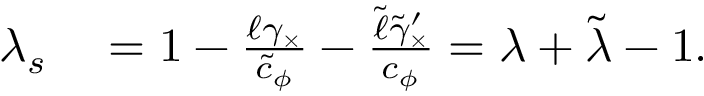Convert formula to latex. <formula><loc_0><loc_0><loc_500><loc_500>\begin{array} { r l } { \lambda _ { s } } & = 1 - \frac { \ell \gamma _ { \times } } { \tilde { c } _ { \phi } } - \frac { \tilde { \ell } \tilde { \gamma } _ { \times } ^ { \prime } } { c _ { \phi } } = \lambda + \tilde { \lambda } - 1 . } \end{array}</formula> 